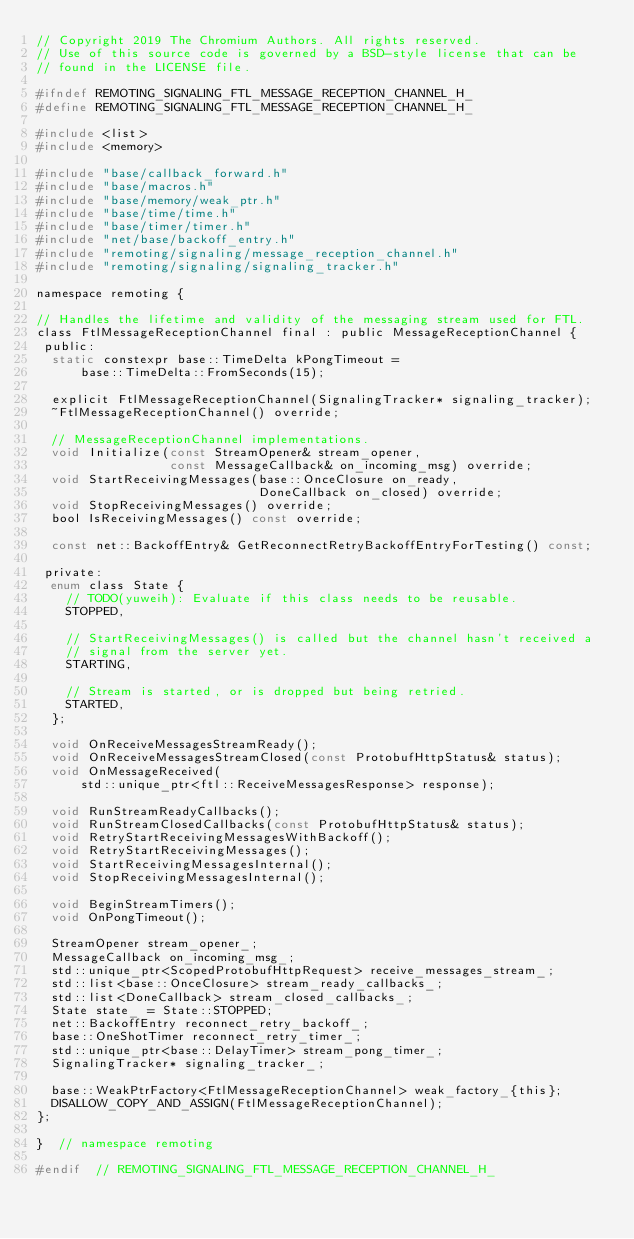Convert code to text. <code><loc_0><loc_0><loc_500><loc_500><_C_>// Copyright 2019 The Chromium Authors. All rights reserved.
// Use of this source code is governed by a BSD-style license that can be
// found in the LICENSE file.

#ifndef REMOTING_SIGNALING_FTL_MESSAGE_RECEPTION_CHANNEL_H_
#define REMOTING_SIGNALING_FTL_MESSAGE_RECEPTION_CHANNEL_H_

#include <list>
#include <memory>

#include "base/callback_forward.h"
#include "base/macros.h"
#include "base/memory/weak_ptr.h"
#include "base/time/time.h"
#include "base/timer/timer.h"
#include "net/base/backoff_entry.h"
#include "remoting/signaling/message_reception_channel.h"
#include "remoting/signaling/signaling_tracker.h"

namespace remoting {

// Handles the lifetime and validity of the messaging stream used for FTL.
class FtlMessageReceptionChannel final : public MessageReceptionChannel {
 public:
  static constexpr base::TimeDelta kPongTimeout =
      base::TimeDelta::FromSeconds(15);

  explicit FtlMessageReceptionChannel(SignalingTracker* signaling_tracker);
  ~FtlMessageReceptionChannel() override;

  // MessageReceptionChannel implementations.
  void Initialize(const StreamOpener& stream_opener,
                  const MessageCallback& on_incoming_msg) override;
  void StartReceivingMessages(base::OnceClosure on_ready,
                              DoneCallback on_closed) override;
  void StopReceivingMessages() override;
  bool IsReceivingMessages() const override;

  const net::BackoffEntry& GetReconnectRetryBackoffEntryForTesting() const;

 private:
  enum class State {
    // TODO(yuweih): Evaluate if this class needs to be reusable.
    STOPPED,

    // StartReceivingMessages() is called but the channel hasn't received a
    // signal from the server yet.
    STARTING,

    // Stream is started, or is dropped but being retried.
    STARTED,
  };

  void OnReceiveMessagesStreamReady();
  void OnReceiveMessagesStreamClosed(const ProtobufHttpStatus& status);
  void OnMessageReceived(
      std::unique_ptr<ftl::ReceiveMessagesResponse> response);

  void RunStreamReadyCallbacks();
  void RunStreamClosedCallbacks(const ProtobufHttpStatus& status);
  void RetryStartReceivingMessagesWithBackoff();
  void RetryStartReceivingMessages();
  void StartReceivingMessagesInternal();
  void StopReceivingMessagesInternal();

  void BeginStreamTimers();
  void OnPongTimeout();

  StreamOpener stream_opener_;
  MessageCallback on_incoming_msg_;
  std::unique_ptr<ScopedProtobufHttpRequest> receive_messages_stream_;
  std::list<base::OnceClosure> stream_ready_callbacks_;
  std::list<DoneCallback> stream_closed_callbacks_;
  State state_ = State::STOPPED;
  net::BackoffEntry reconnect_retry_backoff_;
  base::OneShotTimer reconnect_retry_timer_;
  std::unique_ptr<base::DelayTimer> stream_pong_timer_;
  SignalingTracker* signaling_tracker_;

  base::WeakPtrFactory<FtlMessageReceptionChannel> weak_factory_{this};
  DISALLOW_COPY_AND_ASSIGN(FtlMessageReceptionChannel);
};

}  // namespace remoting

#endif  // REMOTING_SIGNALING_FTL_MESSAGE_RECEPTION_CHANNEL_H_
</code> 